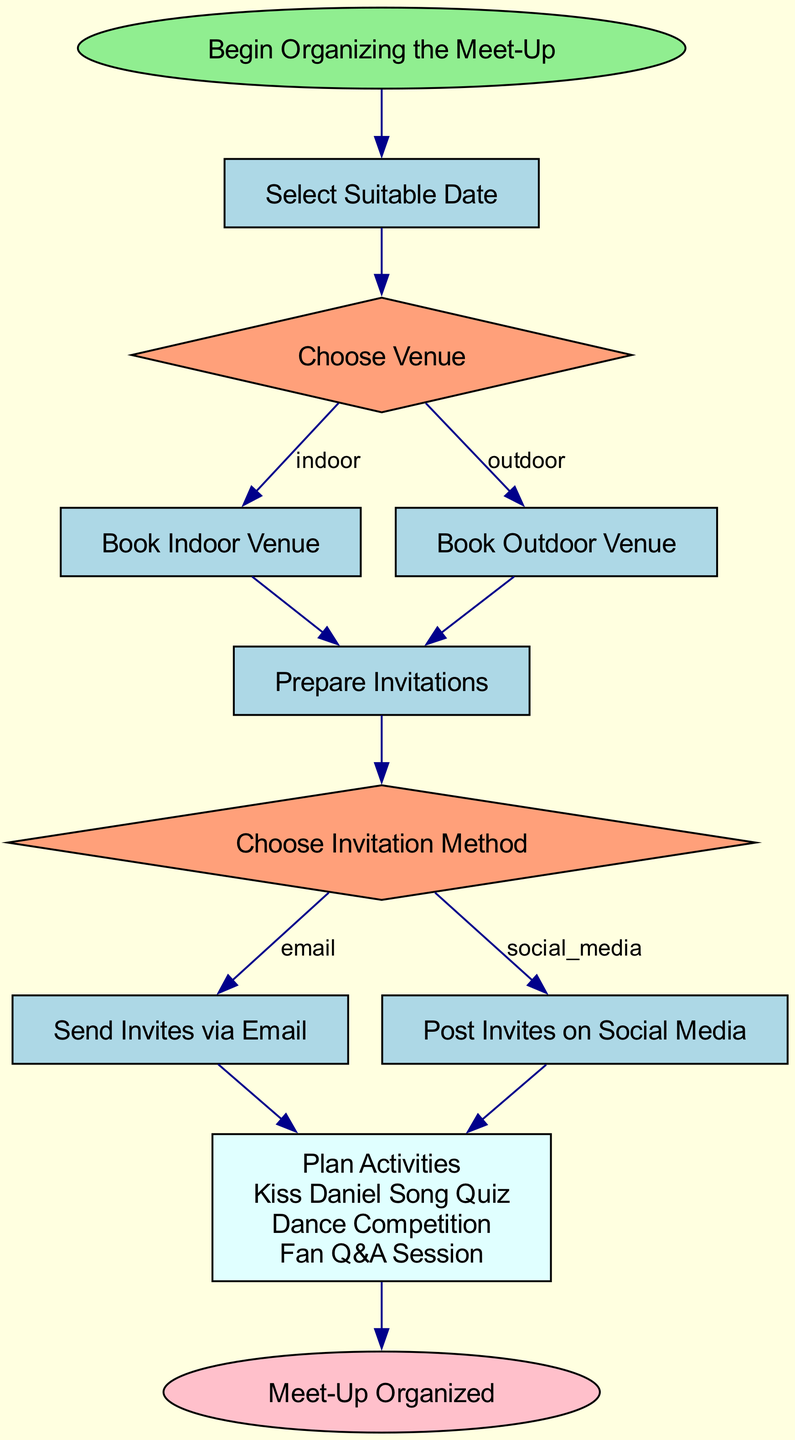what is the first step in organizing the meet-up? The first step in the flowchart is labeled as "Begin Organizing the Meet-Up" which is the starting point of the process.
Answer: Begin Organizing the Meet-Up how many decision nodes are in the diagram? There are two decision nodes in the diagram: "Choose Venue" and "Choose Invitation Method". Each decision node represents a choice that affects the next steps.
Answer: 2 what activities are planned for the meet-up? The planned activities listed under "Plan Activities" are "Kiss Daniel Song Quiz", "Dance Competition", and "Fan Q&A Session". These are the specific activities fans can expect during the meet-up.
Answer: Kiss Daniel Song Quiz, Dance Competition, Fan Q&A Session what are the methods for sending invites? There are two methods for sending invites: "Send Invites via Email" and "Post Invites on Social Media". This highlights the options for reaching out to fans about the meet-up.
Answer: Send Invites via Email, Post Invites on Social Media if an indoor venue is chosen, which step follows? If an indoor venue is chosen, the next step is "Book Indoor Venue". This indicates that choosing an indoor option leads directly to the booking of that venue.
Answer: Book Indoor Venue when does the meet-up get organized according to the flowchart? The meet-up is organized at the end of the flowchart, indicated by the final node labeled "Meet-Up Organized". This signifies that when all previous steps are completed, the organization is complete.
Answer: Meet-Up Organized 